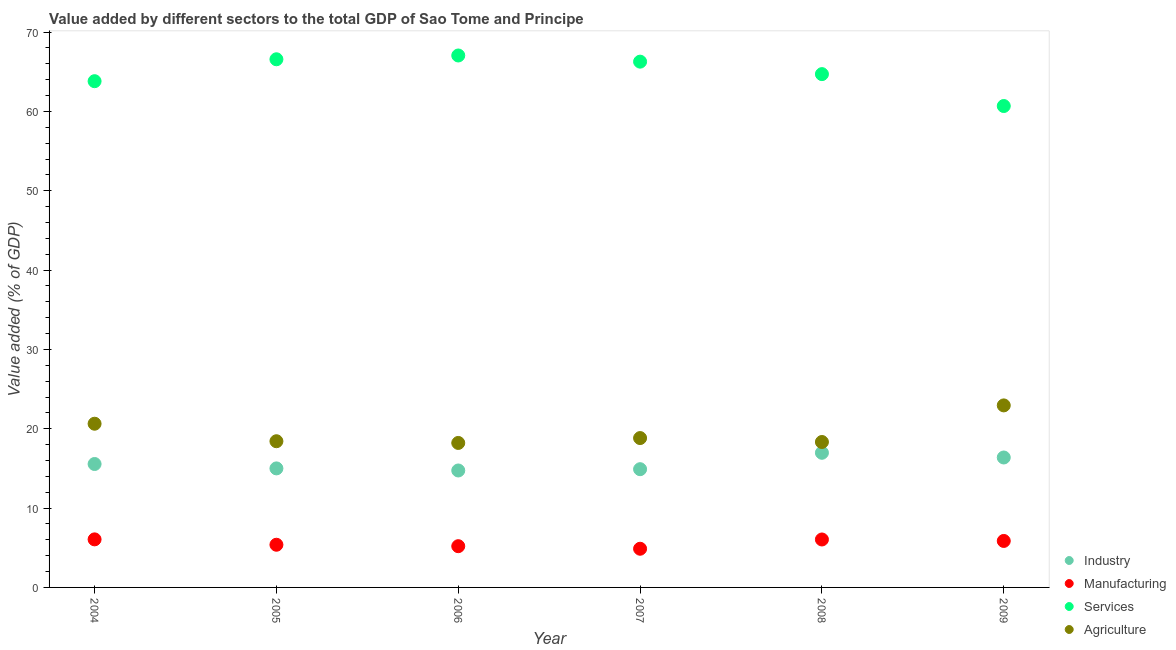How many different coloured dotlines are there?
Provide a short and direct response. 4. What is the value added by services sector in 2005?
Your answer should be compact. 66.57. Across all years, what is the maximum value added by industrial sector?
Offer a terse response. 16.97. Across all years, what is the minimum value added by manufacturing sector?
Give a very brief answer. 4.88. In which year was the value added by agricultural sector maximum?
Give a very brief answer. 2009. What is the total value added by industrial sector in the graph?
Ensure brevity in your answer.  93.55. What is the difference between the value added by manufacturing sector in 2005 and that in 2008?
Give a very brief answer. -0.66. What is the difference between the value added by manufacturing sector in 2007 and the value added by agricultural sector in 2008?
Your response must be concise. -13.46. What is the average value added by services sector per year?
Provide a succinct answer. 64.85. In the year 2005, what is the difference between the value added by industrial sector and value added by services sector?
Your answer should be very brief. -51.57. What is the ratio of the value added by agricultural sector in 2004 to that in 2007?
Make the answer very short. 1.1. Is the value added by services sector in 2006 less than that in 2007?
Ensure brevity in your answer.  No. What is the difference between the highest and the second highest value added by industrial sector?
Offer a terse response. 0.59. What is the difference between the highest and the lowest value added by manufacturing sector?
Offer a terse response. 1.18. In how many years, is the value added by industrial sector greater than the average value added by industrial sector taken over all years?
Offer a terse response. 2. Is it the case that in every year, the sum of the value added by industrial sector and value added by manufacturing sector is greater than the value added by services sector?
Ensure brevity in your answer.  No. How many dotlines are there?
Give a very brief answer. 4. Where does the legend appear in the graph?
Provide a succinct answer. Bottom right. What is the title of the graph?
Provide a short and direct response. Value added by different sectors to the total GDP of Sao Tome and Principe. What is the label or title of the Y-axis?
Your answer should be very brief. Value added (% of GDP). What is the Value added (% of GDP) of Industry in 2004?
Offer a terse response. 15.56. What is the Value added (% of GDP) in Manufacturing in 2004?
Ensure brevity in your answer.  6.06. What is the Value added (% of GDP) of Services in 2004?
Give a very brief answer. 63.81. What is the Value added (% of GDP) in Agriculture in 2004?
Your answer should be very brief. 20.63. What is the Value added (% of GDP) of Industry in 2005?
Ensure brevity in your answer.  15. What is the Value added (% of GDP) of Manufacturing in 2005?
Make the answer very short. 5.38. What is the Value added (% of GDP) of Services in 2005?
Provide a succinct answer. 66.57. What is the Value added (% of GDP) in Agriculture in 2005?
Keep it short and to the point. 18.43. What is the Value added (% of GDP) of Industry in 2006?
Provide a short and direct response. 14.74. What is the Value added (% of GDP) in Manufacturing in 2006?
Make the answer very short. 5.2. What is the Value added (% of GDP) of Services in 2006?
Keep it short and to the point. 67.05. What is the Value added (% of GDP) in Agriculture in 2006?
Your answer should be very brief. 18.21. What is the Value added (% of GDP) in Industry in 2007?
Provide a short and direct response. 14.9. What is the Value added (% of GDP) in Manufacturing in 2007?
Offer a terse response. 4.88. What is the Value added (% of GDP) of Services in 2007?
Make the answer very short. 66.27. What is the Value added (% of GDP) in Agriculture in 2007?
Your answer should be very brief. 18.83. What is the Value added (% of GDP) in Industry in 2008?
Ensure brevity in your answer.  16.97. What is the Value added (% of GDP) in Manufacturing in 2008?
Your answer should be compact. 6.04. What is the Value added (% of GDP) in Services in 2008?
Offer a very short reply. 64.7. What is the Value added (% of GDP) in Agriculture in 2008?
Offer a terse response. 18.33. What is the Value added (% of GDP) of Industry in 2009?
Give a very brief answer. 16.38. What is the Value added (% of GDP) in Manufacturing in 2009?
Make the answer very short. 5.86. What is the Value added (% of GDP) of Services in 2009?
Give a very brief answer. 60.68. What is the Value added (% of GDP) in Agriculture in 2009?
Your answer should be compact. 22.94. Across all years, what is the maximum Value added (% of GDP) in Industry?
Make the answer very short. 16.97. Across all years, what is the maximum Value added (% of GDP) of Manufacturing?
Your answer should be very brief. 6.06. Across all years, what is the maximum Value added (% of GDP) in Services?
Keep it short and to the point. 67.05. Across all years, what is the maximum Value added (% of GDP) of Agriculture?
Your answer should be very brief. 22.94. Across all years, what is the minimum Value added (% of GDP) of Industry?
Your answer should be compact. 14.74. Across all years, what is the minimum Value added (% of GDP) in Manufacturing?
Offer a terse response. 4.88. Across all years, what is the minimum Value added (% of GDP) in Services?
Give a very brief answer. 60.68. Across all years, what is the minimum Value added (% of GDP) in Agriculture?
Your response must be concise. 18.21. What is the total Value added (% of GDP) of Industry in the graph?
Give a very brief answer. 93.55. What is the total Value added (% of GDP) in Manufacturing in the graph?
Offer a very short reply. 33.41. What is the total Value added (% of GDP) in Services in the graph?
Give a very brief answer. 389.07. What is the total Value added (% of GDP) of Agriculture in the graph?
Keep it short and to the point. 117.37. What is the difference between the Value added (% of GDP) in Industry in 2004 and that in 2005?
Give a very brief answer. 0.55. What is the difference between the Value added (% of GDP) of Manufacturing in 2004 and that in 2005?
Your answer should be very brief. 0.68. What is the difference between the Value added (% of GDP) of Services in 2004 and that in 2005?
Offer a very short reply. -2.76. What is the difference between the Value added (% of GDP) in Agriculture in 2004 and that in 2005?
Offer a terse response. 2.21. What is the difference between the Value added (% of GDP) of Industry in 2004 and that in 2006?
Keep it short and to the point. 0.82. What is the difference between the Value added (% of GDP) of Manufacturing in 2004 and that in 2006?
Your answer should be very brief. 0.86. What is the difference between the Value added (% of GDP) in Services in 2004 and that in 2006?
Offer a very short reply. -3.24. What is the difference between the Value added (% of GDP) of Agriculture in 2004 and that in 2006?
Keep it short and to the point. 2.42. What is the difference between the Value added (% of GDP) in Industry in 2004 and that in 2007?
Keep it short and to the point. 0.65. What is the difference between the Value added (% of GDP) in Manufacturing in 2004 and that in 2007?
Your response must be concise. 1.18. What is the difference between the Value added (% of GDP) of Services in 2004 and that in 2007?
Offer a terse response. -2.46. What is the difference between the Value added (% of GDP) in Agriculture in 2004 and that in 2007?
Offer a very short reply. 1.81. What is the difference between the Value added (% of GDP) in Industry in 2004 and that in 2008?
Provide a short and direct response. -1.41. What is the difference between the Value added (% of GDP) of Manufacturing in 2004 and that in 2008?
Provide a succinct answer. 0.01. What is the difference between the Value added (% of GDP) of Services in 2004 and that in 2008?
Your answer should be compact. -0.89. What is the difference between the Value added (% of GDP) of Agriculture in 2004 and that in 2008?
Make the answer very short. 2.3. What is the difference between the Value added (% of GDP) of Industry in 2004 and that in 2009?
Provide a succinct answer. -0.82. What is the difference between the Value added (% of GDP) in Manufacturing in 2004 and that in 2009?
Provide a succinct answer. 0.2. What is the difference between the Value added (% of GDP) in Services in 2004 and that in 2009?
Give a very brief answer. 3.13. What is the difference between the Value added (% of GDP) in Agriculture in 2004 and that in 2009?
Give a very brief answer. -2.31. What is the difference between the Value added (% of GDP) in Industry in 2005 and that in 2006?
Keep it short and to the point. 0.26. What is the difference between the Value added (% of GDP) of Manufacturing in 2005 and that in 2006?
Offer a very short reply. 0.18. What is the difference between the Value added (% of GDP) of Services in 2005 and that in 2006?
Keep it short and to the point. -0.48. What is the difference between the Value added (% of GDP) in Agriculture in 2005 and that in 2006?
Give a very brief answer. 0.22. What is the difference between the Value added (% of GDP) in Industry in 2005 and that in 2007?
Your answer should be very brief. 0.1. What is the difference between the Value added (% of GDP) of Manufacturing in 2005 and that in 2007?
Ensure brevity in your answer.  0.5. What is the difference between the Value added (% of GDP) in Services in 2005 and that in 2007?
Your answer should be compact. 0.3. What is the difference between the Value added (% of GDP) of Agriculture in 2005 and that in 2007?
Your answer should be compact. -0.4. What is the difference between the Value added (% of GDP) of Industry in 2005 and that in 2008?
Your answer should be very brief. -1.97. What is the difference between the Value added (% of GDP) of Manufacturing in 2005 and that in 2008?
Provide a succinct answer. -0.66. What is the difference between the Value added (% of GDP) of Services in 2005 and that in 2008?
Keep it short and to the point. 1.87. What is the difference between the Value added (% of GDP) of Agriculture in 2005 and that in 2008?
Ensure brevity in your answer.  0.1. What is the difference between the Value added (% of GDP) of Industry in 2005 and that in 2009?
Provide a succinct answer. -1.38. What is the difference between the Value added (% of GDP) in Manufacturing in 2005 and that in 2009?
Ensure brevity in your answer.  -0.48. What is the difference between the Value added (% of GDP) of Services in 2005 and that in 2009?
Your response must be concise. 5.89. What is the difference between the Value added (% of GDP) in Agriculture in 2005 and that in 2009?
Your answer should be compact. -4.52. What is the difference between the Value added (% of GDP) of Industry in 2006 and that in 2007?
Ensure brevity in your answer.  -0.16. What is the difference between the Value added (% of GDP) of Manufacturing in 2006 and that in 2007?
Your answer should be very brief. 0.32. What is the difference between the Value added (% of GDP) of Services in 2006 and that in 2007?
Offer a terse response. 0.78. What is the difference between the Value added (% of GDP) in Agriculture in 2006 and that in 2007?
Offer a terse response. -0.61. What is the difference between the Value added (% of GDP) in Industry in 2006 and that in 2008?
Provide a short and direct response. -2.23. What is the difference between the Value added (% of GDP) of Manufacturing in 2006 and that in 2008?
Your answer should be very brief. -0.84. What is the difference between the Value added (% of GDP) in Services in 2006 and that in 2008?
Offer a very short reply. 2.35. What is the difference between the Value added (% of GDP) of Agriculture in 2006 and that in 2008?
Your answer should be very brief. -0.12. What is the difference between the Value added (% of GDP) of Industry in 2006 and that in 2009?
Give a very brief answer. -1.64. What is the difference between the Value added (% of GDP) of Manufacturing in 2006 and that in 2009?
Ensure brevity in your answer.  -0.66. What is the difference between the Value added (% of GDP) of Services in 2006 and that in 2009?
Provide a succinct answer. 6.37. What is the difference between the Value added (% of GDP) of Agriculture in 2006 and that in 2009?
Give a very brief answer. -4.73. What is the difference between the Value added (% of GDP) in Industry in 2007 and that in 2008?
Provide a short and direct response. -2.07. What is the difference between the Value added (% of GDP) of Manufacturing in 2007 and that in 2008?
Give a very brief answer. -1.17. What is the difference between the Value added (% of GDP) in Services in 2007 and that in 2008?
Provide a short and direct response. 1.57. What is the difference between the Value added (% of GDP) of Agriculture in 2007 and that in 2008?
Your response must be concise. 0.5. What is the difference between the Value added (% of GDP) in Industry in 2007 and that in 2009?
Provide a short and direct response. -1.47. What is the difference between the Value added (% of GDP) in Manufacturing in 2007 and that in 2009?
Your answer should be very brief. -0.98. What is the difference between the Value added (% of GDP) in Services in 2007 and that in 2009?
Your response must be concise. 5.59. What is the difference between the Value added (% of GDP) in Agriculture in 2007 and that in 2009?
Keep it short and to the point. -4.12. What is the difference between the Value added (% of GDP) in Industry in 2008 and that in 2009?
Offer a terse response. 0.59. What is the difference between the Value added (% of GDP) of Manufacturing in 2008 and that in 2009?
Give a very brief answer. 0.18. What is the difference between the Value added (% of GDP) in Services in 2008 and that in 2009?
Offer a terse response. 4.02. What is the difference between the Value added (% of GDP) of Agriculture in 2008 and that in 2009?
Offer a terse response. -4.61. What is the difference between the Value added (% of GDP) of Industry in 2004 and the Value added (% of GDP) of Manufacturing in 2005?
Give a very brief answer. 10.18. What is the difference between the Value added (% of GDP) of Industry in 2004 and the Value added (% of GDP) of Services in 2005?
Make the answer very short. -51.01. What is the difference between the Value added (% of GDP) in Industry in 2004 and the Value added (% of GDP) in Agriculture in 2005?
Give a very brief answer. -2.87. What is the difference between the Value added (% of GDP) of Manufacturing in 2004 and the Value added (% of GDP) of Services in 2005?
Keep it short and to the point. -60.51. What is the difference between the Value added (% of GDP) of Manufacturing in 2004 and the Value added (% of GDP) of Agriculture in 2005?
Offer a terse response. -12.37. What is the difference between the Value added (% of GDP) of Services in 2004 and the Value added (% of GDP) of Agriculture in 2005?
Ensure brevity in your answer.  45.38. What is the difference between the Value added (% of GDP) in Industry in 2004 and the Value added (% of GDP) in Manufacturing in 2006?
Offer a terse response. 10.36. What is the difference between the Value added (% of GDP) of Industry in 2004 and the Value added (% of GDP) of Services in 2006?
Offer a very short reply. -51.49. What is the difference between the Value added (% of GDP) in Industry in 2004 and the Value added (% of GDP) in Agriculture in 2006?
Provide a short and direct response. -2.65. What is the difference between the Value added (% of GDP) in Manufacturing in 2004 and the Value added (% of GDP) in Services in 2006?
Offer a very short reply. -60.99. What is the difference between the Value added (% of GDP) in Manufacturing in 2004 and the Value added (% of GDP) in Agriculture in 2006?
Offer a terse response. -12.15. What is the difference between the Value added (% of GDP) of Services in 2004 and the Value added (% of GDP) of Agriculture in 2006?
Make the answer very short. 45.6. What is the difference between the Value added (% of GDP) in Industry in 2004 and the Value added (% of GDP) in Manufacturing in 2007?
Provide a succinct answer. 10.68. What is the difference between the Value added (% of GDP) of Industry in 2004 and the Value added (% of GDP) of Services in 2007?
Give a very brief answer. -50.71. What is the difference between the Value added (% of GDP) in Industry in 2004 and the Value added (% of GDP) in Agriculture in 2007?
Make the answer very short. -3.27. What is the difference between the Value added (% of GDP) of Manufacturing in 2004 and the Value added (% of GDP) of Services in 2007?
Provide a succinct answer. -60.21. What is the difference between the Value added (% of GDP) in Manufacturing in 2004 and the Value added (% of GDP) in Agriculture in 2007?
Give a very brief answer. -12.77. What is the difference between the Value added (% of GDP) of Services in 2004 and the Value added (% of GDP) of Agriculture in 2007?
Make the answer very short. 44.98. What is the difference between the Value added (% of GDP) of Industry in 2004 and the Value added (% of GDP) of Manufacturing in 2008?
Make the answer very short. 9.51. What is the difference between the Value added (% of GDP) of Industry in 2004 and the Value added (% of GDP) of Services in 2008?
Make the answer very short. -49.14. What is the difference between the Value added (% of GDP) in Industry in 2004 and the Value added (% of GDP) in Agriculture in 2008?
Give a very brief answer. -2.77. What is the difference between the Value added (% of GDP) in Manufacturing in 2004 and the Value added (% of GDP) in Services in 2008?
Give a very brief answer. -58.64. What is the difference between the Value added (% of GDP) in Manufacturing in 2004 and the Value added (% of GDP) in Agriculture in 2008?
Keep it short and to the point. -12.27. What is the difference between the Value added (% of GDP) of Services in 2004 and the Value added (% of GDP) of Agriculture in 2008?
Offer a terse response. 45.48. What is the difference between the Value added (% of GDP) in Industry in 2004 and the Value added (% of GDP) in Manufacturing in 2009?
Your answer should be compact. 9.7. What is the difference between the Value added (% of GDP) in Industry in 2004 and the Value added (% of GDP) in Services in 2009?
Ensure brevity in your answer.  -45.12. What is the difference between the Value added (% of GDP) of Industry in 2004 and the Value added (% of GDP) of Agriculture in 2009?
Give a very brief answer. -7.39. What is the difference between the Value added (% of GDP) in Manufacturing in 2004 and the Value added (% of GDP) in Services in 2009?
Provide a succinct answer. -54.62. What is the difference between the Value added (% of GDP) in Manufacturing in 2004 and the Value added (% of GDP) in Agriculture in 2009?
Your answer should be compact. -16.89. What is the difference between the Value added (% of GDP) of Services in 2004 and the Value added (% of GDP) of Agriculture in 2009?
Your answer should be very brief. 40.87. What is the difference between the Value added (% of GDP) of Industry in 2005 and the Value added (% of GDP) of Manufacturing in 2006?
Provide a succinct answer. 9.8. What is the difference between the Value added (% of GDP) of Industry in 2005 and the Value added (% of GDP) of Services in 2006?
Offer a terse response. -52.05. What is the difference between the Value added (% of GDP) in Industry in 2005 and the Value added (% of GDP) in Agriculture in 2006?
Provide a short and direct response. -3.21. What is the difference between the Value added (% of GDP) of Manufacturing in 2005 and the Value added (% of GDP) of Services in 2006?
Keep it short and to the point. -61.67. What is the difference between the Value added (% of GDP) of Manufacturing in 2005 and the Value added (% of GDP) of Agriculture in 2006?
Provide a succinct answer. -12.83. What is the difference between the Value added (% of GDP) of Services in 2005 and the Value added (% of GDP) of Agriculture in 2006?
Your answer should be very brief. 48.36. What is the difference between the Value added (% of GDP) in Industry in 2005 and the Value added (% of GDP) in Manufacturing in 2007?
Make the answer very short. 10.13. What is the difference between the Value added (% of GDP) of Industry in 2005 and the Value added (% of GDP) of Services in 2007?
Offer a terse response. -51.27. What is the difference between the Value added (% of GDP) in Industry in 2005 and the Value added (% of GDP) in Agriculture in 2007?
Your answer should be very brief. -3.82. What is the difference between the Value added (% of GDP) in Manufacturing in 2005 and the Value added (% of GDP) in Services in 2007?
Make the answer very short. -60.89. What is the difference between the Value added (% of GDP) in Manufacturing in 2005 and the Value added (% of GDP) in Agriculture in 2007?
Make the answer very short. -13.45. What is the difference between the Value added (% of GDP) in Services in 2005 and the Value added (% of GDP) in Agriculture in 2007?
Your answer should be very brief. 47.74. What is the difference between the Value added (% of GDP) of Industry in 2005 and the Value added (% of GDP) of Manufacturing in 2008?
Offer a very short reply. 8.96. What is the difference between the Value added (% of GDP) of Industry in 2005 and the Value added (% of GDP) of Services in 2008?
Your answer should be very brief. -49.7. What is the difference between the Value added (% of GDP) of Industry in 2005 and the Value added (% of GDP) of Agriculture in 2008?
Your response must be concise. -3.33. What is the difference between the Value added (% of GDP) in Manufacturing in 2005 and the Value added (% of GDP) in Services in 2008?
Keep it short and to the point. -59.32. What is the difference between the Value added (% of GDP) of Manufacturing in 2005 and the Value added (% of GDP) of Agriculture in 2008?
Keep it short and to the point. -12.95. What is the difference between the Value added (% of GDP) in Services in 2005 and the Value added (% of GDP) in Agriculture in 2008?
Ensure brevity in your answer.  48.24. What is the difference between the Value added (% of GDP) of Industry in 2005 and the Value added (% of GDP) of Manufacturing in 2009?
Offer a terse response. 9.14. What is the difference between the Value added (% of GDP) in Industry in 2005 and the Value added (% of GDP) in Services in 2009?
Offer a very short reply. -45.68. What is the difference between the Value added (% of GDP) in Industry in 2005 and the Value added (% of GDP) in Agriculture in 2009?
Your answer should be compact. -7.94. What is the difference between the Value added (% of GDP) in Manufacturing in 2005 and the Value added (% of GDP) in Services in 2009?
Offer a very short reply. -55.3. What is the difference between the Value added (% of GDP) of Manufacturing in 2005 and the Value added (% of GDP) of Agriculture in 2009?
Give a very brief answer. -17.56. What is the difference between the Value added (% of GDP) in Services in 2005 and the Value added (% of GDP) in Agriculture in 2009?
Your response must be concise. 43.63. What is the difference between the Value added (% of GDP) of Industry in 2006 and the Value added (% of GDP) of Manufacturing in 2007?
Offer a terse response. 9.87. What is the difference between the Value added (% of GDP) of Industry in 2006 and the Value added (% of GDP) of Services in 2007?
Provide a short and direct response. -51.53. What is the difference between the Value added (% of GDP) in Industry in 2006 and the Value added (% of GDP) in Agriculture in 2007?
Ensure brevity in your answer.  -4.09. What is the difference between the Value added (% of GDP) of Manufacturing in 2006 and the Value added (% of GDP) of Services in 2007?
Keep it short and to the point. -61.07. What is the difference between the Value added (% of GDP) of Manufacturing in 2006 and the Value added (% of GDP) of Agriculture in 2007?
Give a very brief answer. -13.63. What is the difference between the Value added (% of GDP) in Services in 2006 and the Value added (% of GDP) in Agriculture in 2007?
Your response must be concise. 48.22. What is the difference between the Value added (% of GDP) in Industry in 2006 and the Value added (% of GDP) in Manufacturing in 2008?
Your answer should be very brief. 8.7. What is the difference between the Value added (% of GDP) of Industry in 2006 and the Value added (% of GDP) of Services in 2008?
Provide a short and direct response. -49.96. What is the difference between the Value added (% of GDP) in Industry in 2006 and the Value added (% of GDP) in Agriculture in 2008?
Ensure brevity in your answer.  -3.59. What is the difference between the Value added (% of GDP) of Manufacturing in 2006 and the Value added (% of GDP) of Services in 2008?
Your answer should be very brief. -59.5. What is the difference between the Value added (% of GDP) of Manufacturing in 2006 and the Value added (% of GDP) of Agriculture in 2008?
Provide a succinct answer. -13.13. What is the difference between the Value added (% of GDP) in Services in 2006 and the Value added (% of GDP) in Agriculture in 2008?
Your response must be concise. 48.72. What is the difference between the Value added (% of GDP) in Industry in 2006 and the Value added (% of GDP) in Manufacturing in 2009?
Make the answer very short. 8.88. What is the difference between the Value added (% of GDP) in Industry in 2006 and the Value added (% of GDP) in Services in 2009?
Offer a terse response. -45.94. What is the difference between the Value added (% of GDP) of Industry in 2006 and the Value added (% of GDP) of Agriculture in 2009?
Offer a very short reply. -8.2. What is the difference between the Value added (% of GDP) of Manufacturing in 2006 and the Value added (% of GDP) of Services in 2009?
Provide a succinct answer. -55.48. What is the difference between the Value added (% of GDP) in Manufacturing in 2006 and the Value added (% of GDP) in Agriculture in 2009?
Keep it short and to the point. -17.75. What is the difference between the Value added (% of GDP) of Services in 2006 and the Value added (% of GDP) of Agriculture in 2009?
Ensure brevity in your answer.  44.1. What is the difference between the Value added (% of GDP) in Industry in 2007 and the Value added (% of GDP) in Manufacturing in 2008?
Ensure brevity in your answer.  8.86. What is the difference between the Value added (% of GDP) of Industry in 2007 and the Value added (% of GDP) of Services in 2008?
Your response must be concise. -49.8. What is the difference between the Value added (% of GDP) in Industry in 2007 and the Value added (% of GDP) in Agriculture in 2008?
Your answer should be compact. -3.43. What is the difference between the Value added (% of GDP) in Manufacturing in 2007 and the Value added (% of GDP) in Services in 2008?
Offer a terse response. -59.82. What is the difference between the Value added (% of GDP) in Manufacturing in 2007 and the Value added (% of GDP) in Agriculture in 2008?
Make the answer very short. -13.46. What is the difference between the Value added (% of GDP) in Services in 2007 and the Value added (% of GDP) in Agriculture in 2008?
Make the answer very short. 47.94. What is the difference between the Value added (% of GDP) in Industry in 2007 and the Value added (% of GDP) in Manufacturing in 2009?
Keep it short and to the point. 9.05. What is the difference between the Value added (% of GDP) of Industry in 2007 and the Value added (% of GDP) of Services in 2009?
Offer a terse response. -45.78. What is the difference between the Value added (% of GDP) in Industry in 2007 and the Value added (% of GDP) in Agriculture in 2009?
Keep it short and to the point. -8.04. What is the difference between the Value added (% of GDP) of Manufacturing in 2007 and the Value added (% of GDP) of Services in 2009?
Make the answer very short. -55.8. What is the difference between the Value added (% of GDP) in Manufacturing in 2007 and the Value added (% of GDP) in Agriculture in 2009?
Give a very brief answer. -18.07. What is the difference between the Value added (% of GDP) in Services in 2007 and the Value added (% of GDP) in Agriculture in 2009?
Provide a short and direct response. 43.33. What is the difference between the Value added (% of GDP) in Industry in 2008 and the Value added (% of GDP) in Manufacturing in 2009?
Provide a succinct answer. 11.11. What is the difference between the Value added (% of GDP) in Industry in 2008 and the Value added (% of GDP) in Services in 2009?
Give a very brief answer. -43.71. What is the difference between the Value added (% of GDP) in Industry in 2008 and the Value added (% of GDP) in Agriculture in 2009?
Make the answer very short. -5.97. What is the difference between the Value added (% of GDP) of Manufacturing in 2008 and the Value added (% of GDP) of Services in 2009?
Give a very brief answer. -54.64. What is the difference between the Value added (% of GDP) of Manufacturing in 2008 and the Value added (% of GDP) of Agriculture in 2009?
Provide a succinct answer. -16.9. What is the difference between the Value added (% of GDP) in Services in 2008 and the Value added (% of GDP) in Agriculture in 2009?
Keep it short and to the point. 41.76. What is the average Value added (% of GDP) of Industry per year?
Provide a short and direct response. 15.59. What is the average Value added (% of GDP) in Manufacturing per year?
Your answer should be compact. 5.57. What is the average Value added (% of GDP) of Services per year?
Make the answer very short. 64.85. What is the average Value added (% of GDP) of Agriculture per year?
Keep it short and to the point. 19.56. In the year 2004, what is the difference between the Value added (% of GDP) of Industry and Value added (% of GDP) of Manufacturing?
Provide a succinct answer. 9.5. In the year 2004, what is the difference between the Value added (% of GDP) of Industry and Value added (% of GDP) of Services?
Give a very brief answer. -48.25. In the year 2004, what is the difference between the Value added (% of GDP) of Industry and Value added (% of GDP) of Agriculture?
Keep it short and to the point. -5.08. In the year 2004, what is the difference between the Value added (% of GDP) of Manufacturing and Value added (% of GDP) of Services?
Your answer should be compact. -57.75. In the year 2004, what is the difference between the Value added (% of GDP) of Manufacturing and Value added (% of GDP) of Agriculture?
Your answer should be very brief. -14.58. In the year 2004, what is the difference between the Value added (% of GDP) in Services and Value added (% of GDP) in Agriculture?
Keep it short and to the point. 43.17. In the year 2005, what is the difference between the Value added (% of GDP) in Industry and Value added (% of GDP) in Manufacturing?
Your answer should be compact. 9.62. In the year 2005, what is the difference between the Value added (% of GDP) of Industry and Value added (% of GDP) of Services?
Provide a succinct answer. -51.57. In the year 2005, what is the difference between the Value added (% of GDP) in Industry and Value added (% of GDP) in Agriculture?
Give a very brief answer. -3.42. In the year 2005, what is the difference between the Value added (% of GDP) in Manufacturing and Value added (% of GDP) in Services?
Give a very brief answer. -61.19. In the year 2005, what is the difference between the Value added (% of GDP) in Manufacturing and Value added (% of GDP) in Agriculture?
Your response must be concise. -13.05. In the year 2005, what is the difference between the Value added (% of GDP) in Services and Value added (% of GDP) in Agriculture?
Offer a terse response. 48.14. In the year 2006, what is the difference between the Value added (% of GDP) in Industry and Value added (% of GDP) in Manufacturing?
Offer a very short reply. 9.54. In the year 2006, what is the difference between the Value added (% of GDP) in Industry and Value added (% of GDP) in Services?
Offer a very short reply. -52.31. In the year 2006, what is the difference between the Value added (% of GDP) in Industry and Value added (% of GDP) in Agriculture?
Ensure brevity in your answer.  -3.47. In the year 2006, what is the difference between the Value added (% of GDP) of Manufacturing and Value added (% of GDP) of Services?
Your answer should be very brief. -61.85. In the year 2006, what is the difference between the Value added (% of GDP) of Manufacturing and Value added (% of GDP) of Agriculture?
Your response must be concise. -13.01. In the year 2006, what is the difference between the Value added (% of GDP) of Services and Value added (% of GDP) of Agriculture?
Your answer should be very brief. 48.84. In the year 2007, what is the difference between the Value added (% of GDP) of Industry and Value added (% of GDP) of Manufacturing?
Your answer should be very brief. 10.03. In the year 2007, what is the difference between the Value added (% of GDP) of Industry and Value added (% of GDP) of Services?
Make the answer very short. -51.37. In the year 2007, what is the difference between the Value added (% of GDP) in Industry and Value added (% of GDP) in Agriculture?
Keep it short and to the point. -3.92. In the year 2007, what is the difference between the Value added (% of GDP) in Manufacturing and Value added (% of GDP) in Services?
Provide a short and direct response. -61.4. In the year 2007, what is the difference between the Value added (% of GDP) of Manufacturing and Value added (% of GDP) of Agriculture?
Your response must be concise. -13.95. In the year 2007, what is the difference between the Value added (% of GDP) of Services and Value added (% of GDP) of Agriculture?
Offer a terse response. 47.44. In the year 2008, what is the difference between the Value added (% of GDP) in Industry and Value added (% of GDP) in Manufacturing?
Offer a very short reply. 10.93. In the year 2008, what is the difference between the Value added (% of GDP) in Industry and Value added (% of GDP) in Services?
Your response must be concise. -47.73. In the year 2008, what is the difference between the Value added (% of GDP) of Industry and Value added (% of GDP) of Agriculture?
Keep it short and to the point. -1.36. In the year 2008, what is the difference between the Value added (% of GDP) in Manufacturing and Value added (% of GDP) in Services?
Your response must be concise. -58.66. In the year 2008, what is the difference between the Value added (% of GDP) of Manufacturing and Value added (% of GDP) of Agriculture?
Your answer should be very brief. -12.29. In the year 2008, what is the difference between the Value added (% of GDP) of Services and Value added (% of GDP) of Agriculture?
Make the answer very short. 46.37. In the year 2009, what is the difference between the Value added (% of GDP) in Industry and Value added (% of GDP) in Manufacturing?
Your answer should be very brief. 10.52. In the year 2009, what is the difference between the Value added (% of GDP) of Industry and Value added (% of GDP) of Services?
Provide a succinct answer. -44.3. In the year 2009, what is the difference between the Value added (% of GDP) of Industry and Value added (% of GDP) of Agriculture?
Your answer should be very brief. -6.57. In the year 2009, what is the difference between the Value added (% of GDP) of Manufacturing and Value added (% of GDP) of Services?
Give a very brief answer. -54.82. In the year 2009, what is the difference between the Value added (% of GDP) in Manufacturing and Value added (% of GDP) in Agriculture?
Your response must be concise. -17.09. In the year 2009, what is the difference between the Value added (% of GDP) of Services and Value added (% of GDP) of Agriculture?
Offer a very short reply. 37.74. What is the ratio of the Value added (% of GDP) in Manufacturing in 2004 to that in 2005?
Your response must be concise. 1.13. What is the ratio of the Value added (% of GDP) in Services in 2004 to that in 2005?
Your answer should be compact. 0.96. What is the ratio of the Value added (% of GDP) of Agriculture in 2004 to that in 2005?
Provide a succinct answer. 1.12. What is the ratio of the Value added (% of GDP) in Industry in 2004 to that in 2006?
Keep it short and to the point. 1.06. What is the ratio of the Value added (% of GDP) in Manufacturing in 2004 to that in 2006?
Make the answer very short. 1.17. What is the ratio of the Value added (% of GDP) of Services in 2004 to that in 2006?
Your answer should be compact. 0.95. What is the ratio of the Value added (% of GDP) in Agriculture in 2004 to that in 2006?
Keep it short and to the point. 1.13. What is the ratio of the Value added (% of GDP) of Industry in 2004 to that in 2007?
Your response must be concise. 1.04. What is the ratio of the Value added (% of GDP) of Manufacturing in 2004 to that in 2007?
Your response must be concise. 1.24. What is the ratio of the Value added (% of GDP) in Services in 2004 to that in 2007?
Ensure brevity in your answer.  0.96. What is the ratio of the Value added (% of GDP) in Agriculture in 2004 to that in 2007?
Your response must be concise. 1.1. What is the ratio of the Value added (% of GDP) of Industry in 2004 to that in 2008?
Offer a very short reply. 0.92. What is the ratio of the Value added (% of GDP) in Manufacturing in 2004 to that in 2008?
Offer a terse response. 1. What is the ratio of the Value added (% of GDP) of Services in 2004 to that in 2008?
Your answer should be very brief. 0.99. What is the ratio of the Value added (% of GDP) in Agriculture in 2004 to that in 2008?
Keep it short and to the point. 1.13. What is the ratio of the Value added (% of GDP) in Industry in 2004 to that in 2009?
Your answer should be very brief. 0.95. What is the ratio of the Value added (% of GDP) in Manufacturing in 2004 to that in 2009?
Offer a very short reply. 1.03. What is the ratio of the Value added (% of GDP) of Services in 2004 to that in 2009?
Keep it short and to the point. 1.05. What is the ratio of the Value added (% of GDP) of Agriculture in 2004 to that in 2009?
Keep it short and to the point. 0.9. What is the ratio of the Value added (% of GDP) in Industry in 2005 to that in 2006?
Provide a succinct answer. 1.02. What is the ratio of the Value added (% of GDP) in Manufacturing in 2005 to that in 2006?
Your answer should be very brief. 1.03. What is the ratio of the Value added (% of GDP) in Services in 2005 to that in 2006?
Provide a succinct answer. 0.99. What is the ratio of the Value added (% of GDP) in Agriculture in 2005 to that in 2006?
Your answer should be very brief. 1.01. What is the ratio of the Value added (% of GDP) in Industry in 2005 to that in 2007?
Make the answer very short. 1.01. What is the ratio of the Value added (% of GDP) in Manufacturing in 2005 to that in 2007?
Keep it short and to the point. 1.1. What is the ratio of the Value added (% of GDP) in Agriculture in 2005 to that in 2007?
Provide a short and direct response. 0.98. What is the ratio of the Value added (% of GDP) of Industry in 2005 to that in 2008?
Keep it short and to the point. 0.88. What is the ratio of the Value added (% of GDP) in Manufacturing in 2005 to that in 2008?
Offer a very short reply. 0.89. What is the ratio of the Value added (% of GDP) in Services in 2005 to that in 2008?
Your answer should be compact. 1.03. What is the ratio of the Value added (% of GDP) of Agriculture in 2005 to that in 2008?
Ensure brevity in your answer.  1.01. What is the ratio of the Value added (% of GDP) in Industry in 2005 to that in 2009?
Your response must be concise. 0.92. What is the ratio of the Value added (% of GDP) of Manufacturing in 2005 to that in 2009?
Your answer should be compact. 0.92. What is the ratio of the Value added (% of GDP) of Services in 2005 to that in 2009?
Ensure brevity in your answer.  1.1. What is the ratio of the Value added (% of GDP) in Agriculture in 2005 to that in 2009?
Your answer should be compact. 0.8. What is the ratio of the Value added (% of GDP) of Manufacturing in 2006 to that in 2007?
Provide a succinct answer. 1.07. What is the ratio of the Value added (% of GDP) in Services in 2006 to that in 2007?
Your response must be concise. 1.01. What is the ratio of the Value added (% of GDP) of Agriculture in 2006 to that in 2007?
Keep it short and to the point. 0.97. What is the ratio of the Value added (% of GDP) of Industry in 2006 to that in 2008?
Your response must be concise. 0.87. What is the ratio of the Value added (% of GDP) in Manufacturing in 2006 to that in 2008?
Offer a terse response. 0.86. What is the ratio of the Value added (% of GDP) of Services in 2006 to that in 2008?
Make the answer very short. 1.04. What is the ratio of the Value added (% of GDP) of Agriculture in 2006 to that in 2008?
Offer a very short reply. 0.99. What is the ratio of the Value added (% of GDP) of Manufacturing in 2006 to that in 2009?
Ensure brevity in your answer.  0.89. What is the ratio of the Value added (% of GDP) in Services in 2006 to that in 2009?
Your response must be concise. 1.1. What is the ratio of the Value added (% of GDP) in Agriculture in 2006 to that in 2009?
Give a very brief answer. 0.79. What is the ratio of the Value added (% of GDP) in Industry in 2007 to that in 2008?
Make the answer very short. 0.88. What is the ratio of the Value added (% of GDP) in Manufacturing in 2007 to that in 2008?
Your response must be concise. 0.81. What is the ratio of the Value added (% of GDP) of Services in 2007 to that in 2008?
Your answer should be compact. 1.02. What is the ratio of the Value added (% of GDP) of Industry in 2007 to that in 2009?
Keep it short and to the point. 0.91. What is the ratio of the Value added (% of GDP) in Manufacturing in 2007 to that in 2009?
Give a very brief answer. 0.83. What is the ratio of the Value added (% of GDP) of Services in 2007 to that in 2009?
Your answer should be very brief. 1.09. What is the ratio of the Value added (% of GDP) in Agriculture in 2007 to that in 2009?
Keep it short and to the point. 0.82. What is the ratio of the Value added (% of GDP) in Industry in 2008 to that in 2009?
Your answer should be very brief. 1.04. What is the ratio of the Value added (% of GDP) of Manufacturing in 2008 to that in 2009?
Offer a very short reply. 1.03. What is the ratio of the Value added (% of GDP) of Services in 2008 to that in 2009?
Your answer should be very brief. 1.07. What is the ratio of the Value added (% of GDP) of Agriculture in 2008 to that in 2009?
Make the answer very short. 0.8. What is the difference between the highest and the second highest Value added (% of GDP) of Industry?
Give a very brief answer. 0.59. What is the difference between the highest and the second highest Value added (% of GDP) of Manufacturing?
Offer a very short reply. 0.01. What is the difference between the highest and the second highest Value added (% of GDP) in Services?
Offer a very short reply. 0.48. What is the difference between the highest and the second highest Value added (% of GDP) in Agriculture?
Offer a very short reply. 2.31. What is the difference between the highest and the lowest Value added (% of GDP) of Industry?
Ensure brevity in your answer.  2.23. What is the difference between the highest and the lowest Value added (% of GDP) in Manufacturing?
Give a very brief answer. 1.18. What is the difference between the highest and the lowest Value added (% of GDP) of Services?
Provide a short and direct response. 6.37. What is the difference between the highest and the lowest Value added (% of GDP) of Agriculture?
Provide a short and direct response. 4.73. 